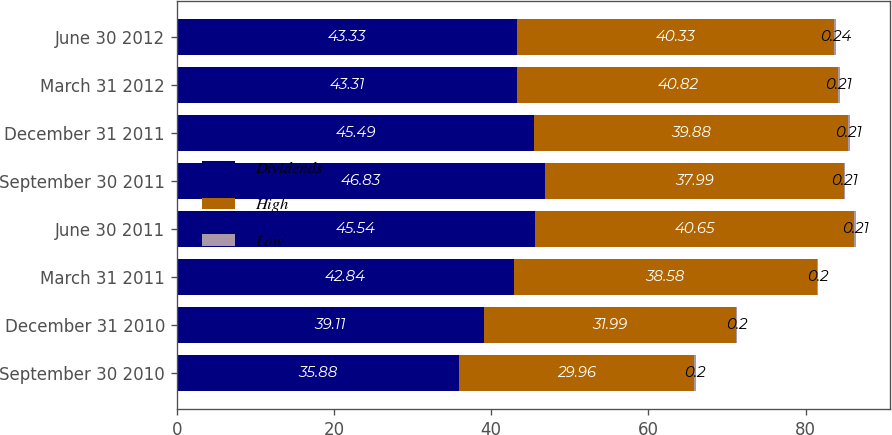Convert chart. <chart><loc_0><loc_0><loc_500><loc_500><stacked_bar_chart><ecel><fcel>September 30 2010<fcel>December 31 2010<fcel>March 31 2011<fcel>June 30 2011<fcel>September 30 2011<fcel>December 31 2011<fcel>March 31 2012<fcel>June 30 2012<nl><fcel>Dividends<fcel>35.88<fcel>39.11<fcel>42.84<fcel>45.54<fcel>46.83<fcel>45.49<fcel>43.31<fcel>43.33<nl><fcel>High<fcel>29.96<fcel>31.99<fcel>38.58<fcel>40.65<fcel>37.99<fcel>39.88<fcel>40.82<fcel>40.33<nl><fcel>Low<fcel>0.2<fcel>0.2<fcel>0.2<fcel>0.21<fcel>0.21<fcel>0.21<fcel>0.21<fcel>0.24<nl></chart> 